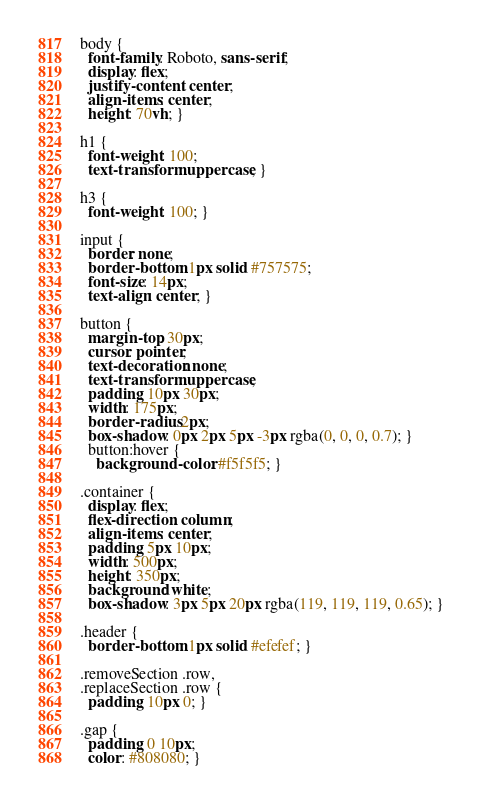<code> <loc_0><loc_0><loc_500><loc_500><_CSS_>
body {
  font-family: Roboto, sans-serif;
  display: flex;
  justify-content: center;
  align-items: center;
  height: 70vh; }

h1 {
  font-weight: 100;
  text-transform: uppercase; }

h3 {
  font-weight: 100; }

input {
  border: none;
  border-bottom: 1px solid #757575;
  font-size: 14px;
  text-align: center; }

button {
  margin-top: 30px;
  cursor: pointer;
  text-decoration: none;
  text-transform: uppercase;
  padding: 10px 30px;
  width: 175px;
  border-radius: 2px;
  box-shadow: 0px 2px 5px -3px rgba(0, 0, 0, 0.7); }
  button:hover {
    background-color: #f5f5f5; }

.container {
  display: flex;
  flex-direction: column;
  align-items: center;
  padding: 5px 10px;
  width: 500px;
  height: 350px;
  background: white;
  box-shadow: 3px 5px 20px rgba(119, 119, 119, 0.65); }

.header {
  border-bottom: 1px solid #efefef; }

.removeSection .row,
.replaceSection .row {
  padding: 10px 0; }

.gap {
  padding: 0 10px;
  color: #808080; }
</code> 